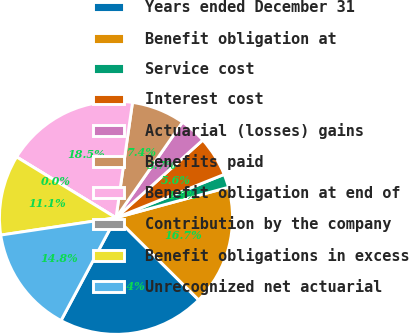Convert chart. <chart><loc_0><loc_0><loc_500><loc_500><pie_chart><fcel>Years ended December 31<fcel>Benefit obligation at<fcel>Service cost<fcel>Interest cost<fcel>Actuarial (losses) gains<fcel>Benefits paid<fcel>Benefit obligation at end of<fcel>Contribution by the company<fcel>Benefit obligations in excess<fcel>Unrecognized net actuarial<nl><fcel>20.37%<fcel>16.67%<fcel>1.85%<fcel>5.56%<fcel>3.7%<fcel>7.41%<fcel>18.52%<fcel>0.0%<fcel>11.11%<fcel>14.81%<nl></chart> 